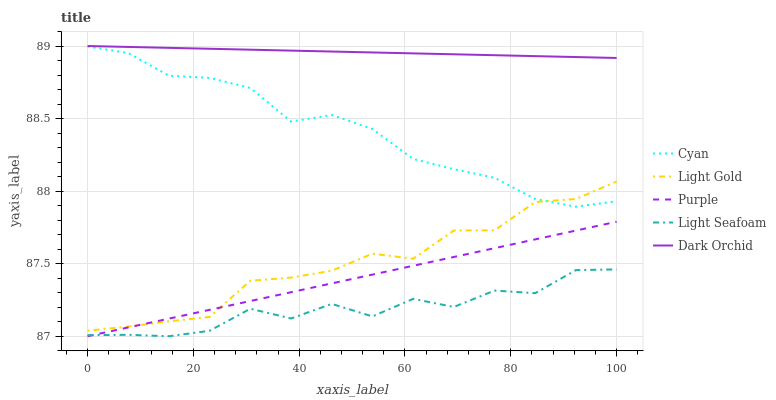Does Light Seafoam have the minimum area under the curve?
Answer yes or no. Yes. Does Dark Orchid have the maximum area under the curve?
Answer yes or no. Yes. Does Cyan have the minimum area under the curve?
Answer yes or no. No. Does Cyan have the maximum area under the curve?
Answer yes or no. No. Is Purple the smoothest?
Answer yes or no. Yes. Is Light Seafoam the roughest?
Answer yes or no. Yes. Is Cyan the smoothest?
Answer yes or no. No. Is Cyan the roughest?
Answer yes or no. No. Does Purple have the lowest value?
Answer yes or no. Yes. Does Cyan have the lowest value?
Answer yes or no. No. Does Dark Orchid have the highest value?
Answer yes or no. Yes. Does Cyan have the highest value?
Answer yes or no. No. Is Cyan less than Dark Orchid?
Answer yes or no. Yes. Is Dark Orchid greater than Light Seafoam?
Answer yes or no. Yes. Does Light Gold intersect Cyan?
Answer yes or no. Yes. Is Light Gold less than Cyan?
Answer yes or no. No. Is Light Gold greater than Cyan?
Answer yes or no. No. Does Cyan intersect Dark Orchid?
Answer yes or no. No. 